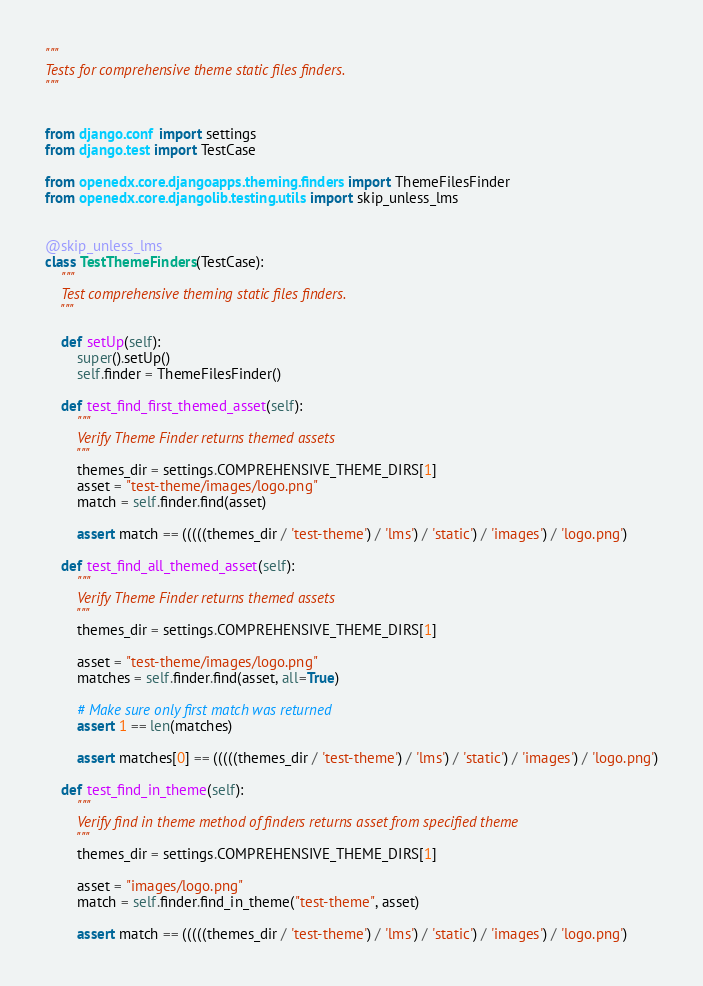<code> <loc_0><loc_0><loc_500><loc_500><_Python_>"""
Tests for comprehensive theme static files finders.
"""


from django.conf import settings
from django.test import TestCase

from openedx.core.djangoapps.theming.finders import ThemeFilesFinder
from openedx.core.djangolib.testing.utils import skip_unless_lms


@skip_unless_lms
class TestThemeFinders(TestCase):
    """
    Test comprehensive theming static files finders.
    """

    def setUp(self):
        super().setUp()
        self.finder = ThemeFilesFinder()

    def test_find_first_themed_asset(self):
        """
        Verify Theme Finder returns themed assets
        """
        themes_dir = settings.COMPREHENSIVE_THEME_DIRS[1]
        asset = "test-theme/images/logo.png"
        match = self.finder.find(asset)

        assert match == (((((themes_dir / 'test-theme') / 'lms') / 'static') / 'images') / 'logo.png')

    def test_find_all_themed_asset(self):
        """
        Verify Theme Finder returns themed assets
        """
        themes_dir = settings.COMPREHENSIVE_THEME_DIRS[1]

        asset = "test-theme/images/logo.png"
        matches = self.finder.find(asset, all=True)

        # Make sure only first match was returned
        assert 1 == len(matches)

        assert matches[0] == (((((themes_dir / 'test-theme') / 'lms') / 'static') / 'images') / 'logo.png')

    def test_find_in_theme(self):
        """
        Verify find in theme method of finders returns asset from specified theme
        """
        themes_dir = settings.COMPREHENSIVE_THEME_DIRS[1]

        asset = "images/logo.png"
        match = self.finder.find_in_theme("test-theme", asset)

        assert match == (((((themes_dir / 'test-theme') / 'lms') / 'static') / 'images') / 'logo.png')
</code> 